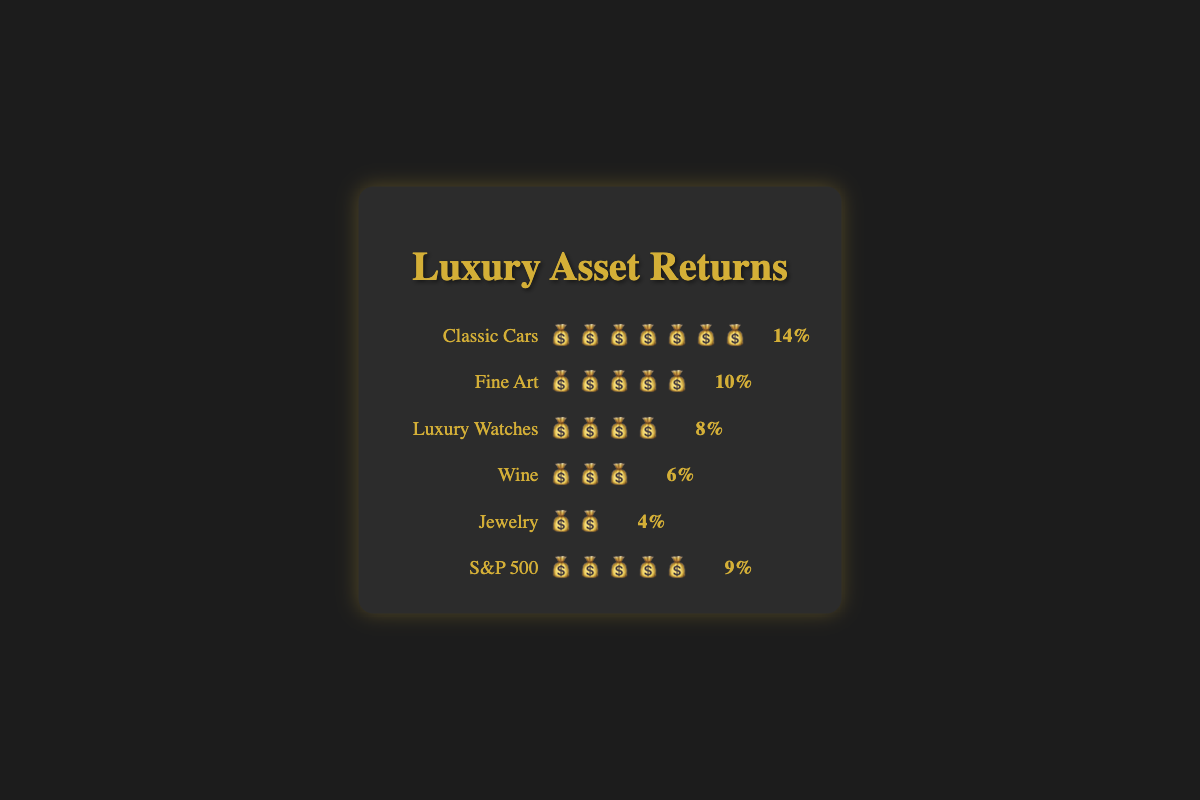Which asset has the highest return and what is that return? The figure shows Classic Cars have the highest return with seven money bag emojis, which corresponds to a return of 14%.
Answer: Classic Cars, 14% Which asset has the lowest return and what is that return? The figure indicates Jewelry has the lowest return with two money bag emojis, which corresponds to a return of 4%.
Answer: Jewelry, 4% How does the return of Classic Cars compare to Luxury Watches? Classic Cars have seven money bag emojis (14% return), while Luxury Watches have four money bag emojis (8% return). Comparing these, Classic Cars have a higher return.
Answer: Classic Cars have a higher return What is the combined return of Fine Art and Wine? Fine Art has five money bag emojis representing a 10% return, and Wine has three money bag emojis representing a 6% return. Their combined return is 10% + 6%.
Answer: 16% Which assets have the same return as the S&P 500? The figure shows the S&P 500 has five money bag emojis representing a 9% return. Fine Art also has five money bag emojis.
Answer: Fine Art What is the difference in return between Wine and Jewelry? Wine has three money bag emojis representing a 6% return, and Jewelry has two money bag emojis representing a 4% return. The difference is 6% - 4%.
Answer: 2% Rank the assets from highest to lowest return. Based on the number of money bag emojis and their corresponding returns: Classic Cars (14%), Fine Art (10%), S&P 500 (9%), Luxury Watches (8%), Wine (6%), Jewelry (4%).
Answer: Classic Cars, Fine Art, S&P 500, Luxury Watches, Wine, Jewelry Which asset categories have a return less than Luxury Watches? Luxury Watches have a return of 8% (four money bag emojis). Assets with returns less than 8% are Wine (6%) and Jewelry (4%).
Answer: Wine, Jewelry If I invest in both Classic Cars and Fine Art, what is my average return? Classic Cars have a 14% return, and Fine Art has a 10% return. The average return is (14% + 10%) / 2.
Answer: 12% How many different assets have a return of at least 10%? The assets with at least 10% return are Classic Cars (14%) and Fine Art (10%).
Answer: 2 